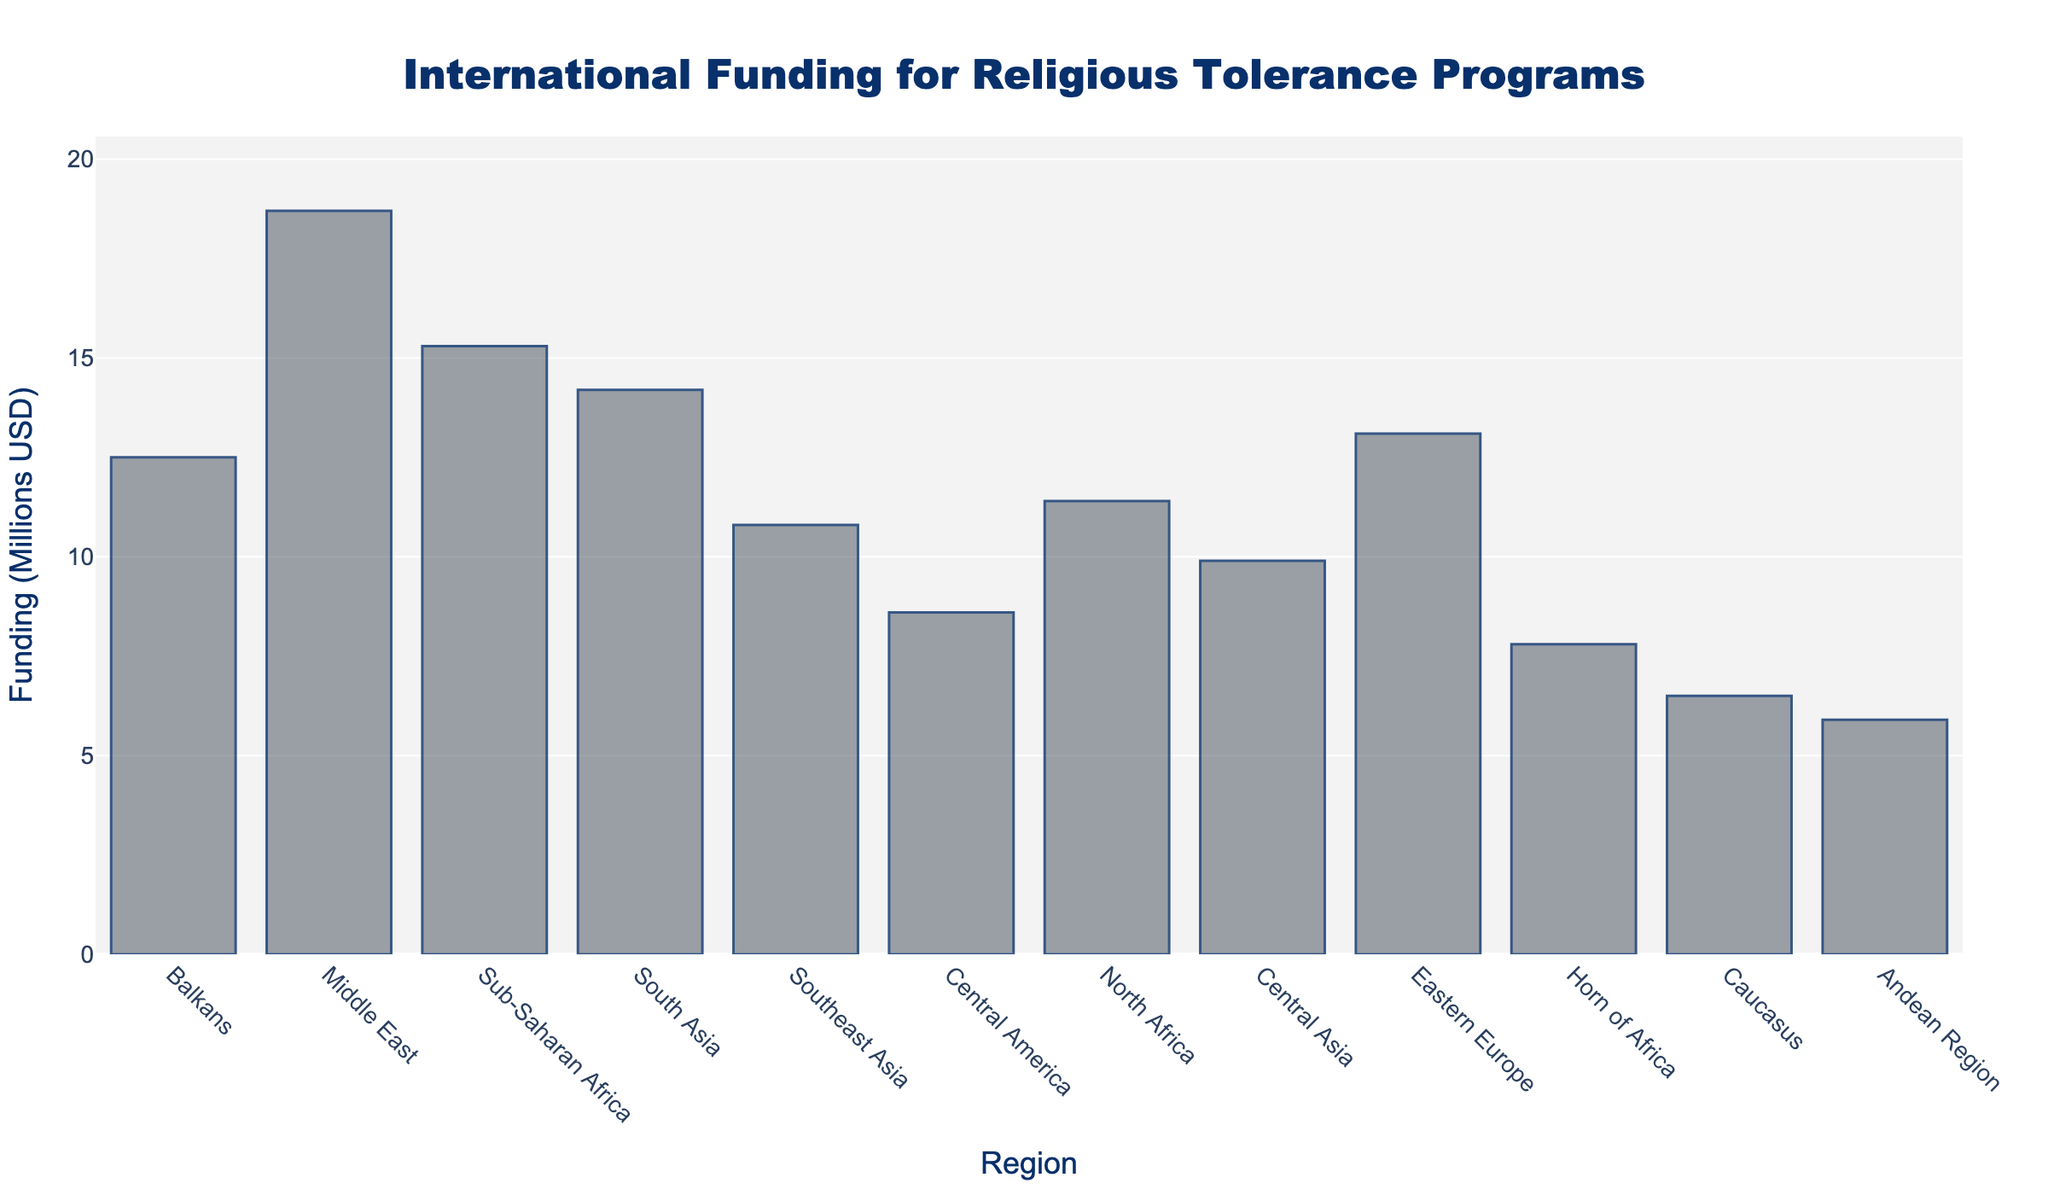Which region received the highest amount of funding? The bar for the Middle East is the tallest in the chart, indicating it received the highest amount of funding.
Answer: Middle East Which region received the lowest amount of funding? The bar for the Andean Region is the shortest in the chart, indicating it received the lowest amount of funding.
Answer: Andean Region What is the total funding received by regions in Sub-Saharan Africa and South Asia? Sub-Saharan Africa received 15.3 million USD, and South Asia received 14.2 million USD; summing them gives 15.3 + 14.2 = 29.5 million USD.
Answer: 29.5 Is the funding for North Africa greater than that for Central Asia? The bar for North Africa (11.4) is higher than the bar for Central Asia (9.9), indicating North Africa's funding is greater.
Answer: Yes What is the average funding received across all regions? Sum all the amounts: 12.5 + 18.7 + 15.3 + 14.2 + 10.8 + 8.6 + 11.4 + 9.9 + 13.1 + 7.8 + 6.5 + 5.9 = 134.7. There are 12 regions, so the average is 134.7 / 12 ≈ 11.225 million USD.
Answer: 11.225 Which region's funding is closest to the average funding? The average funding is approximately 11.225 million USD. North Africa's funding (11.4 million USD) is the closest to this value.
Answer: North Africa How much more funding did the Middle East receive compared to the Balkans? The Middle East received 18.7 million USD, and the Balkans received 12.5 million USD; the difference is 18.7 - 12.5 = 6.2 million USD.
Answer: 6.2 What is the median funding amount across all regions? Ordering the funding amounts: 5.9, 6.5, 7.8, 8.6, 9.9, 10.8, 11.4, 12.5, 13.1, 14.2, 15.3, 18.7. The median is the average of the 6th and 7th values: (10.8 + 11.4) / 2 = 11.1 million USD.
Answer: 11.1 